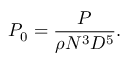Convert formula to latex. <formula><loc_0><loc_0><loc_500><loc_500>P _ { 0 } = \frac { P } { \rho N ^ { 3 } D ^ { 5 } } .</formula> 